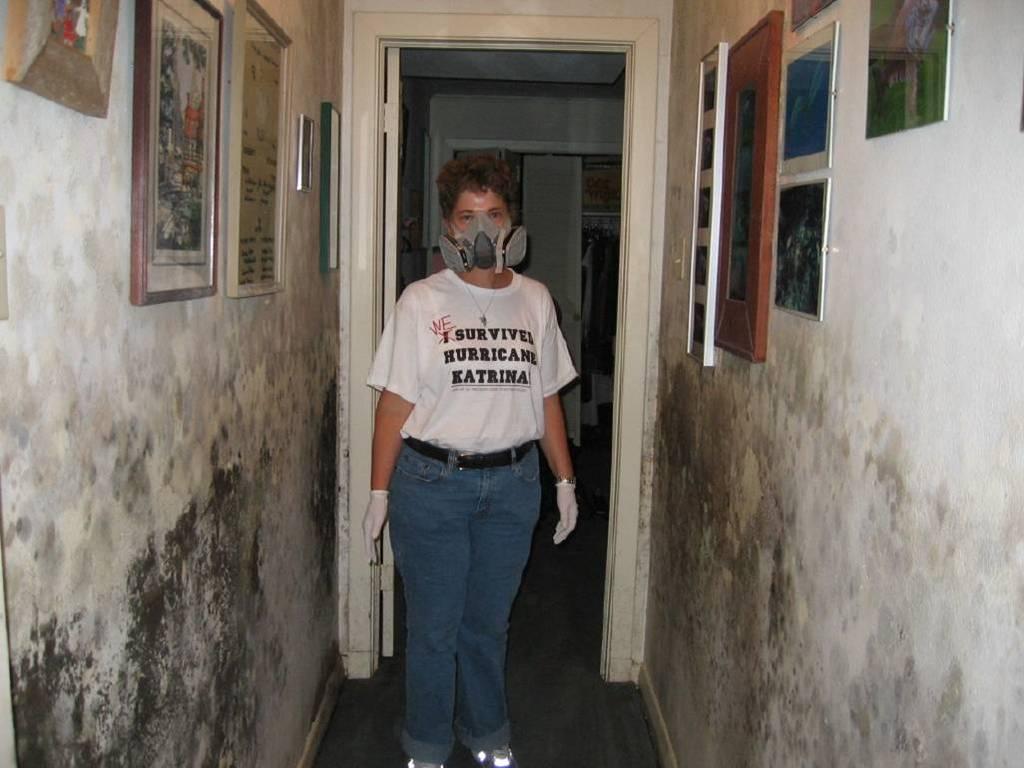In one or two sentences, can you explain what this image depicts? Here a person is standing wearing mask, here there are photo frames on the wall, this is door. 